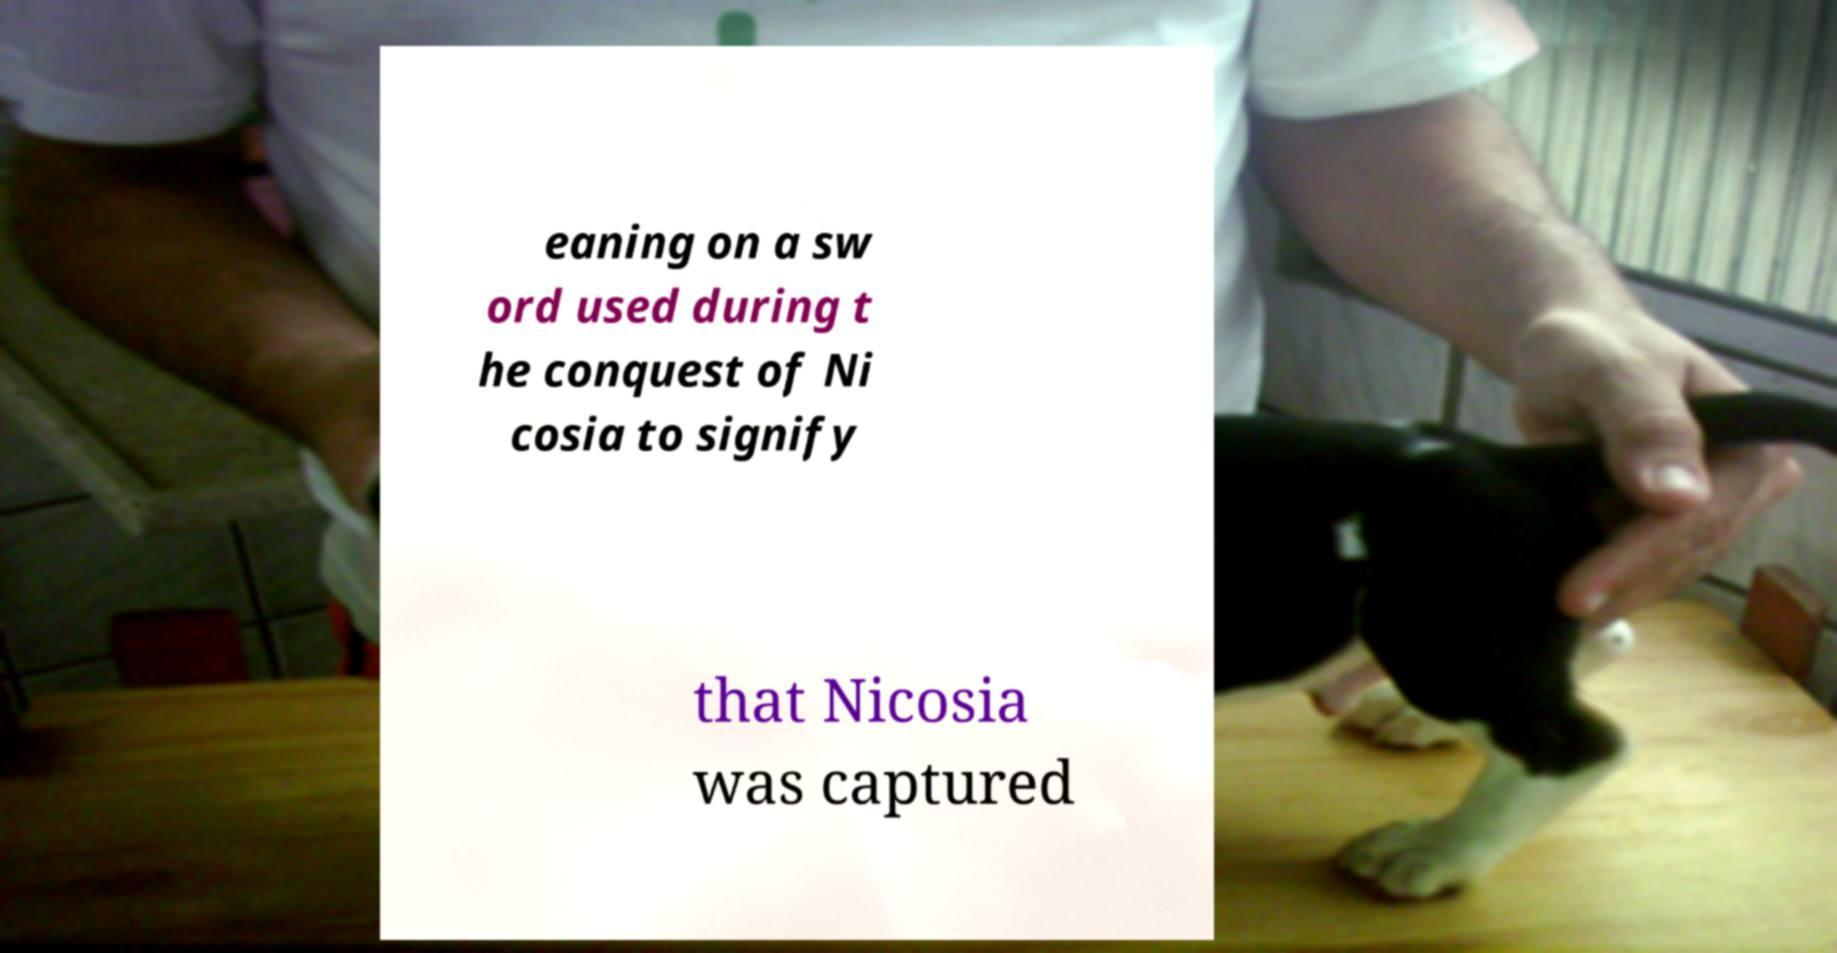Can you accurately transcribe the text from the provided image for me? eaning on a sw ord used during t he conquest of Ni cosia to signify that Nicosia was captured 